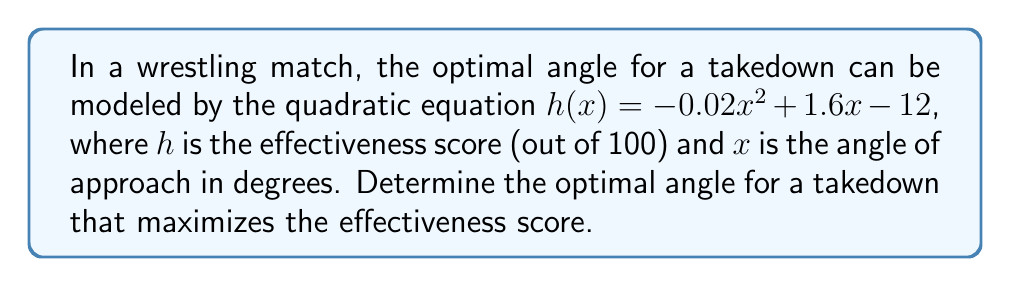Can you answer this question? To find the optimal angle, we need to determine the vertex of the parabola, which represents the maximum point of the quadratic function.

1) The quadratic function is in the form $h(x) = ax^2 + bx + c$, where:
   $a = -0.02$
   $b = 1.6$
   $c = -12$

2) For a quadratic function $f(x) = ax^2 + bx + c$, the x-coordinate of the vertex is given by $x = -\frac{b}{2a}$

3) Substituting our values:
   $x = -\frac{1.6}{2(-0.02)} = -\frac{1.6}{-0.04} = 40$

4) To verify this is a maximum (not a minimum), we check that $a < 0$, which is true in this case.

5) Therefore, the optimal angle is 40 degrees.

6) To find the maximum effectiveness score, we substitute $x = 40$ into the original equation:

   $h(40) = -0.02(40)^2 + 1.6(40) - 12$
   $= -0.02(1600) + 64 - 12$
   $= -32 + 64 - 12$
   $= 20$

Thus, the maximum effectiveness score is 20 out of 100.
Answer: The optimal angle for a takedown is 40 degrees, which yields a maximum effectiveness score of 20 out of 100. 